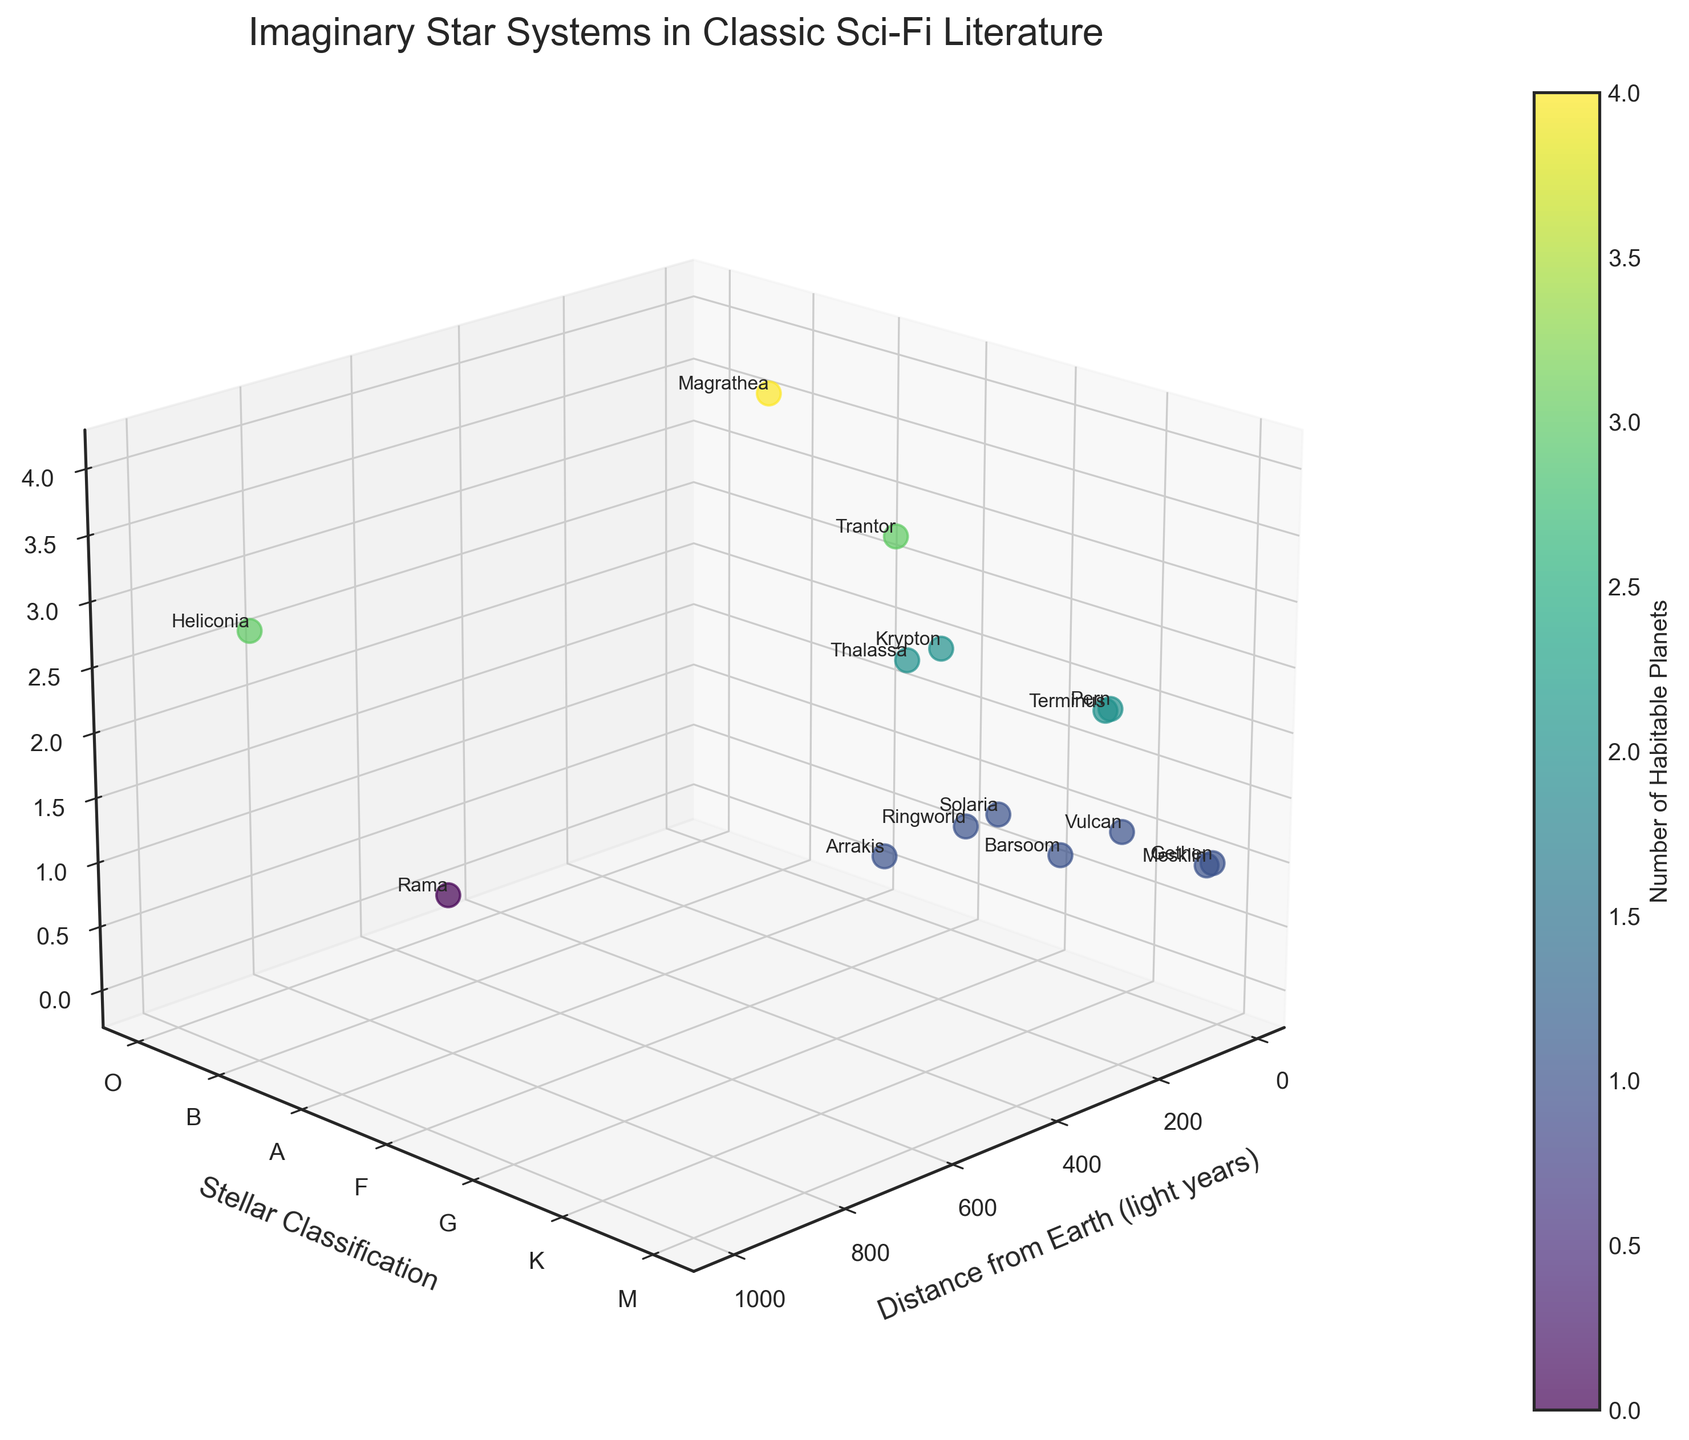What is the title of the figure? The title is displayed at the top of the figure, "Imaginary Star Systems in Classic Sci-Fi Literature".
Answer: Imaginary Star Systems in Classic Sci-Fi Literature How many star systems have a G-type star classification? The y-axis shows the stellar classifications labeled from 'O' to 'M'. Count the points at the G-level, which are G0V and G2V. There are two points: Solaria and Ringworld.
Answer: 2 Which star system is furthest from Earth? The x-axis indicates the distance from Earth in light years. The highest value appears to be at 1000 light years, and the label at this point is Heliconia.
Answer: Heliconia How many systems have exactly 2 habitable planets? The z-axis shows the number of habitable planets. Count the points at the z=2 level: there are Pern, Krypton, Terminus, and Thalassa, making a total of 4.
Answer: 4 Which star system has no habitable planets? Identify any star system plotted at the z=0 level. The label at this point is Rama.
Answer: Rama What is the average distance from Earth for all star systems? Adding up all distances (310 + 120 + 45 + 16 + 85 + 27 + 200 + 150 + 1000 + 55 + 30 + 140 + 500 + 18 + 95) gives 2791 light years. Dividing by 15 star systems gives an average of 186.07 light years.
Answer: 186.07 Which star system has the highest number of habitable planets? Look for the highest value along the z-axis (Number of Habitable Planets). Magrathea reaches the highest point at 4 habitable planets.
Answer: Magrathea Which star systems are within 100 light years from Earth and have more than 1 habitable planet? Points with a distance <100 light years and z >1 include Trantor (120 light years, excluded), Pern (45 ly, 2 planets), Krypton (27 ly, 2 planets), Terminus (55 ly, 2 planets), and Thalassa (95 ly, 2 planets). These are Pern, Krypton, Terminus, and Thalassa.
Answer: Pern, Krypton, Terminus, Thalassa Are there more star systems with K-type stars or F-type stars? Count points with K-type stars on the y-axis. K1V, K2V, and K5V give us Vulcan, Pern, Terminus, and Barsoom, totaling 4. Points with F-type stars include Trantor, Krypton, Heliconia, and Thalassa, also totaling 4.
Answer: Equal 